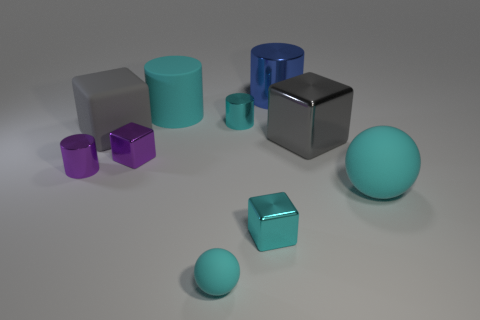What number of large objects are either rubber things or purple metallic balls?
Make the answer very short. 3. Is the size of the rubber block the same as the cyan rubber ball that is in front of the cyan cube?
Ensure brevity in your answer.  No. What number of other objects are the same shape as the blue metal thing?
Keep it short and to the point. 3. There is a large blue thing that is made of the same material as the tiny purple cylinder; what is its shape?
Your answer should be compact. Cylinder. Are any big yellow metallic cylinders visible?
Offer a terse response. No. Are there fewer tiny cubes left of the tiny matte ball than gray matte objects behind the gray matte object?
Keep it short and to the point. No. What is the shape of the large rubber thing in front of the rubber block?
Your response must be concise. Sphere. Do the tiny purple cylinder and the large blue cylinder have the same material?
Provide a short and direct response. Yes. Is there anything else that is made of the same material as the tiny cyan cylinder?
Make the answer very short. Yes. What is the material of the large cyan thing that is the same shape as the tiny matte thing?
Give a very brief answer. Rubber. 